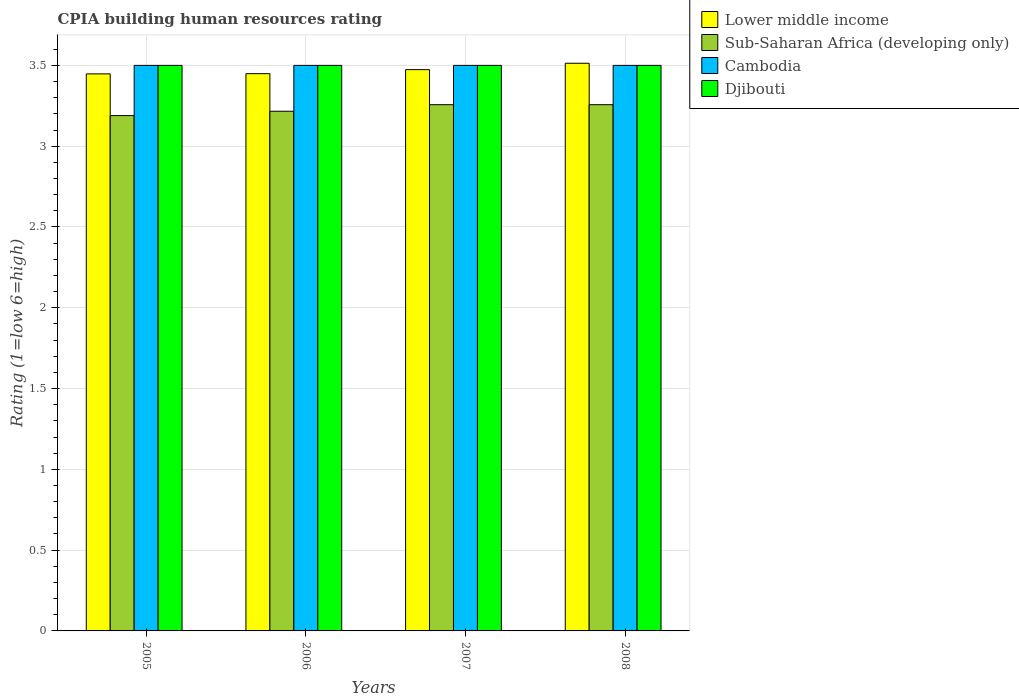How many different coloured bars are there?
Your response must be concise. 4. Are the number of bars per tick equal to the number of legend labels?
Your answer should be compact. Yes. In how many cases, is the number of bars for a given year not equal to the number of legend labels?
Provide a short and direct response. 0. What is the CPIA rating in Sub-Saharan Africa (developing only) in 2005?
Offer a very short reply. 3.19. Across all years, what is the minimum CPIA rating in Djibouti?
Your answer should be compact. 3.5. In which year was the CPIA rating in Sub-Saharan Africa (developing only) maximum?
Your answer should be compact. 2007. What is the difference between the CPIA rating in Sub-Saharan Africa (developing only) in 2005 and that in 2008?
Offer a very short reply. -0.07. What is the difference between the CPIA rating in Djibouti in 2007 and the CPIA rating in Cambodia in 2008?
Give a very brief answer. 0. What is the average CPIA rating in Sub-Saharan Africa (developing only) per year?
Offer a very short reply. 3.23. In the year 2008, what is the difference between the CPIA rating in Cambodia and CPIA rating in Lower middle income?
Your answer should be compact. -0.01. What is the ratio of the CPIA rating in Lower middle income in 2006 to that in 2008?
Your answer should be very brief. 0.98. Is the CPIA rating in Sub-Saharan Africa (developing only) in 2005 less than that in 2006?
Your answer should be compact. Yes. In how many years, is the CPIA rating in Lower middle income greater than the average CPIA rating in Lower middle income taken over all years?
Provide a succinct answer. 2. Is the sum of the CPIA rating in Sub-Saharan Africa (developing only) in 2005 and 2006 greater than the maximum CPIA rating in Cambodia across all years?
Your answer should be very brief. Yes. Is it the case that in every year, the sum of the CPIA rating in Sub-Saharan Africa (developing only) and CPIA rating in Djibouti is greater than the sum of CPIA rating in Cambodia and CPIA rating in Lower middle income?
Provide a short and direct response. No. What does the 1st bar from the left in 2006 represents?
Provide a short and direct response. Lower middle income. What does the 4th bar from the right in 2006 represents?
Your answer should be compact. Lower middle income. Is it the case that in every year, the sum of the CPIA rating in Sub-Saharan Africa (developing only) and CPIA rating in Djibouti is greater than the CPIA rating in Cambodia?
Provide a short and direct response. Yes. Are all the bars in the graph horizontal?
Your response must be concise. No. Are the values on the major ticks of Y-axis written in scientific E-notation?
Give a very brief answer. No. Does the graph contain any zero values?
Your response must be concise. No. Where does the legend appear in the graph?
Your answer should be compact. Top right. How many legend labels are there?
Keep it short and to the point. 4. How are the legend labels stacked?
Offer a very short reply. Vertical. What is the title of the graph?
Give a very brief answer. CPIA building human resources rating. What is the label or title of the Y-axis?
Offer a terse response. Rating (1=low 6=high). What is the Rating (1=low 6=high) in Lower middle income in 2005?
Ensure brevity in your answer.  3.45. What is the Rating (1=low 6=high) in Sub-Saharan Africa (developing only) in 2005?
Your response must be concise. 3.19. What is the Rating (1=low 6=high) of Djibouti in 2005?
Offer a terse response. 3.5. What is the Rating (1=low 6=high) in Lower middle income in 2006?
Your answer should be very brief. 3.45. What is the Rating (1=low 6=high) in Sub-Saharan Africa (developing only) in 2006?
Ensure brevity in your answer.  3.22. What is the Rating (1=low 6=high) in Cambodia in 2006?
Give a very brief answer. 3.5. What is the Rating (1=low 6=high) of Lower middle income in 2007?
Ensure brevity in your answer.  3.47. What is the Rating (1=low 6=high) of Sub-Saharan Africa (developing only) in 2007?
Make the answer very short. 3.26. What is the Rating (1=low 6=high) in Lower middle income in 2008?
Offer a terse response. 3.51. What is the Rating (1=low 6=high) of Sub-Saharan Africa (developing only) in 2008?
Your response must be concise. 3.26. What is the Rating (1=low 6=high) of Djibouti in 2008?
Keep it short and to the point. 3.5. Across all years, what is the maximum Rating (1=low 6=high) of Lower middle income?
Give a very brief answer. 3.51. Across all years, what is the maximum Rating (1=low 6=high) in Sub-Saharan Africa (developing only)?
Offer a terse response. 3.26. Across all years, what is the maximum Rating (1=low 6=high) of Cambodia?
Offer a very short reply. 3.5. Across all years, what is the minimum Rating (1=low 6=high) of Lower middle income?
Your response must be concise. 3.45. Across all years, what is the minimum Rating (1=low 6=high) of Sub-Saharan Africa (developing only)?
Give a very brief answer. 3.19. Across all years, what is the minimum Rating (1=low 6=high) of Cambodia?
Your response must be concise. 3.5. What is the total Rating (1=low 6=high) in Lower middle income in the graph?
Provide a succinct answer. 13.88. What is the total Rating (1=low 6=high) in Sub-Saharan Africa (developing only) in the graph?
Offer a terse response. 12.92. What is the total Rating (1=low 6=high) of Cambodia in the graph?
Give a very brief answer. 14. What is the difference between the Rating (1=low 6=high) in Lower middle income in 2005 and that in 2006?
Keep it short and to the point. -0. What is the difference between the Rating (1=low 6=high) in Sub-Saharan Africa (developing only) in 2005 and that in 2006?
Provide a short and direct response. -0.03. What is the difference between the Rating (1=low 6=high) of Cambodia in 2005 and that in 2006?
Your answer should be very brief. 0. What is the difference between the Rating (1=low 6=high) of Lower middle income in 2005 and that in 2007?
Provide a succinct answer. -0.03. What is the difference between the Rating (1=low 6=high) in Sub-Saharan Africa (developing only) in 2005 and that in 2007?
Your answer should be compact. -0.07. What is the difference between the Rating (1=low 6=high) of Cambodia in 2005 and that in 2007?
Your response must be concise. 0. What is the difference between the Rating (1=low 6=high) in Djibouti in 2005 and that in 2007?
Provide a succinct answer. 0. What is the difference between the Rating (1=low 6=high) in Lower middle income in 2005 and that in 2008?
Your answer should be very brief. -0.07. What is the difference between the Rating (1=low 6=high) of Sub-Saharan Africa (developing only) in 2005 and that in 2008?
Your response must be concise. -0.07. What is the difference between the Rating (1=low 6=high) in Djibouti in 2005 and that in 2008?
Your answer should be compact. 0. What is the difference between the Rating (1=low 6=high) in Lower middle income in 2006 and that in 2007?
Offer a very short reply. -0.03. What is the difference between the Rating (1=low 6=high) of Sub-Saharan Africa (developing only) in 2006 and that in 2007?
Ensure brevity in your answer.  -0.04. What is the difference between the Rating (1=low 6=high) of Cambodia in 2006 and that in 2007?
Your response must be concise. 0. What is the difference between the Rating (1=low 6=high) in Djibouti in 2006 and that in 2007?
Provide a succinct answer. 0. What is the difference between the Rating (1=low 6=high) in Lower middle income in 2006 and that in 2008?
Provide a succinct answer. -0.06. What is the difference between the Rating (1=low 6=high) in Sub-Saharan Africa (developing only) in 2006 and that in 2008?
Provide a short and direct response. -0.04. What is the difference between the Rating (1=low 6=high) in Djibouti in 2006 and that in 2008?
Offer a very short reply. 0. What is the difference between the Rating (1=low 6=high) in Lower middle income in 2007 and that in 2008?
Your answer should be very brief. -0.04. What is the difference between the Rating (1=low 6=high) of Cambodia in 2007 and that in 2008?
Give a very brief answer. 0. What is the difference between the Rating (1=low 6=high) in Djibouti in 2007 and that in 2008?
Ensure brevity in your answer.  0. What is the difference between the Rating (1=low 6=high) in Lower middle income in 2005 and the Rating (1=low 6=high) in Sub-Saharan Africa (developing only) in 2006?
Ensure brevity in your answer.  0.23. What is the difference between the Rating (1=low 6=high) of Lower middle income in 2005 and the Rating (1=low 6=high) of Cambodia in 2006?
Your answer should be very brief. -0.05. What is the difference between the Rating (1=low 6=high) in Lower middle income in 2005 and the Rating (1=low 6=high) in Djibouti in 2006?
Keep it short and to the point. -0.05. What is the difference between the Rating (1=low 6=high) of Sub-Saharan Africa (developing only) in 2005 and the Rating (1=low 6=high) of Cambodia in 2006?
Offer a very short reply. -0.31. What is the difference between the Rating (1=low 6=high) in Sub-Saharan Africa (developing only) in 2005 and the Rating (1=low 6=high) in Djibouti in 2006?
Provide a short and direct response. -0.31. What is the difference between the Rating (1=low 6=high) in Cambodia in 2005 and the Rating (1=low 6=high) in Djibouti in 2006?
Provide a short and direct response. 0. What is the difference between the Rating (1=low 6=high) of Lower middle income in 2005 and the Rating (1=low 6=high) of Sub-Saharan Africa (developing only) in 2007?
Provide a succinct answer. 0.19. What is the difference between the Rating (1=low 6=high) in Lower middle income in 2005 and the Rating (1=low 6=high) in Cambodia in 2007?
Make the answer very short. -0.05. What is the difference between the Rating (1=low 6=high) of Lower middle income in 2005 and the Rating (1=low 6=high) of Djibouti in 2007?
Provide a short and direct response. -0.05. What is the difference between the Rating (1=low 6=high) in Sub-Saharan Africa (developing only) in 2005 and the Rating (1=low 6=high) in Cambodia in 2007?
Keep it short and to the point. -0.31. What is the difference between the Rating (1=low 6=high) of Sub-Saharan Africa (developing only) in 2005 and the Rating (1=low 6=high) of Djibouti in 2007?
Provide a short and direct response. -0.31. What is the difference between the Rating (1=low 6=high) of Lower middle income in 2005 and the Rating (1=low 6=high) of Sub-Saharan Africa (developing only) in 2008?
Provide a succinct answer. 0.19. What is the difference between the Rating (1=low 6=high) of Lower middle income in 2005 and the Rating (1=low 6=high) of Cambodia in 2008?
Give a very brief answer. -0.05. What is the difference between the Rating (1=low 6=high) in Lower middle income in 2005 and the Rating (1=low 6=high) in Djibouti in 2008?
Make the answer very short. -0.05. What is the difference between the Rating (1=low 6=high) in Sub-Saharan Africa (developing only) in 2005 and the Rating (1=low 6=high) in Cambodia in 2008?
Offer a very short reply. -0.31. What is the difference between the Rating (1=low 6=high) of Sub-Saharan Africa (developing only) in 2005 and the Rating (1=low 6=high) of Djibouti in 2008?
Provide a short and direct response. -0.31. What is the difference between the Rating (1=low 6=high) of Cambodia in 2005 and the Rating (1=low 6=high) of Djibouti in 2008?
Provide a short and direct response. 0. What is the difference between the Rating (1=low 6=high) of Lower middle income in 2006 and the Rating (1=low 6=high) of Sub-Saharan Africa (developing only) in 2007?
Provide a succinct answer. 0.19. What is the difference between the Rating (1=low 6=high) of Lower middle income in 2006 and the Rating (1=low 6=high) of Cambodia in 2007?
Keep it short and to the point. -0.05. What is the difference between the Rating (1=low 6=high) in Lower middle income in 2006 and the Rating (1=low 6=high) in Djibouti in 2007?
Ensure brevity in your answer.  -0.05. What is the difference between the Rating (1=low 6=high) of Sub-Saharan Africa (developing only) in 2006 and the Rating (1=low 6=high) of Cambodia in 2007?
Your answer should be compact. -0.28. What is the difference between the Rating (1=low 6=high) of Sub-Saharan Africa (developing only) in 2006 and the Rating (1=low 6=high) of Djibouti in 2007?
Provide a succinct answer. -0.28. What is the difference between the Rating (1=low 6=high) in Lower middle income in 2006 and the Rating (1=low 6=high) in Sub-Saharan Africa (developing only) in 2008?
Your answer should be very brief. 0.19. What is the difference between the Rating (1=low 6=high) of Lower middle income in 2006 and the Rating (1=low 6=high) of Cambodia in 2008?
Make the answer very short. -0.05. What is the difference between the Rating (1=low 6=high) of Lower middle income in 2006 and the Rating (1=low 6=high) of Djibouti in 2008?
Provide a succinct answer. -0.05. What is the difference between the Rating (1=low 6=high) of Sub-Saharan Africa (developing only) in 2006 and the Rating (1=low 6=high) of Cambodia in 2008?
Provide a short and direct response. -0.28. What is the difference between the Rating (1=low 6=high) of Sub-Saharan Africa (developing only) in 2006 and the Rating (1=low 6=high) of Djibouti in 2008?
Provide a short and direct response. -0.28. What is the difference between the Rating (1=low 6=high) of Cambodia in 2006 and the Rating (1=low 6=high) of Djibouti in 2008?
Keep it short and to the point. 0. What is the difference between the Rating (1=low 6=high) in Lower middle income in 2007 and the Rating (1=low 6=high) in Sub-Saharan Africa (developing only) in 2008?
Your response must be concise. 0.22. What is the difference between the Rating (1=low 6=high) in Lower middle income in 2007 and the Rating (1=low 6=high) in Cambodia in 2008?
Your answer should be very brief. -0.03. What is the difference between the Rating (1=low 6=high) in Lower middle income in 2007 and the Rating (1=low 6=high) in Djibouti in 2008?
Your answer should be very brief. -0.03. What is the difference between the Rating (1=low 6=high) of Sub-Saharan Africa (developing only) in 2007 and the Rating (1=low 6=high) of Cambodia in 2008?
Provide a short and direct response. -0.24. What is the difference between the Rating (1=low 6=high) of Sub-Saharan Africa (developing only) in 2007 and the Rating (1=low 6=high) of Djibouti in 2008?
Give a very brief answer. -0.24. What is the difference between the Rating (1=low 6=high) in Cambodia in 2007 and the Rating (1=low 6=high) in Djibouti in 2008?
Provide a succinct answer. 0. What is the average Rating (1=low 6=high) in Lower middle income per year?
Offer a terse response. 3.47. What is the average Rating (1=low 6=high) of Sub-Saharan Africa (developing only) per year?
Make the answer very short. 3.23. In the year 2005, what is the difference between the Rating (1=low 6=high) of Lower middle income and Rating (1=low 6=high) of Sub-Saharan Africa (developing only)?
Provide a succinct answer. 0.26. In the year 2005, what is the difference between the Rating (1=low 6=high) of Lower middle income and Rating (1=low 6=high) of Cambodia?
Your answer should be compact. -0.05. In the year 2005, what is the difference between the Rating (1=low 6=high) of Lower middle income and Rating (1=low 6=high) of Djibouti?
Provide a succinct answer. -0.05. In the year 2005, what is the difference between the Rating (1=low 6=high) of Sub-Saharan Africa (developing only) and Rating (1=low 6=high) of Cambodia?
Keep it short and to the point. -0.31. In the year 2005, what is the difference between the Rating (1=low 6=high) of Sub-Saharan Africa (developing only) and Rating (1=low 6=high) of Djibouti?
Offer a terse response. -0.31. In the year 2005, what is the difference between the Rating (1=low 6=high) in Cambodia and Rating (1=low 6=high) in Djibouti?
Keep it short and to the point. 0. In the year 2006, what is the difference between the Rating (1=low 6=high) in Lower middle income and Rating (1=low 6=high) in Sub-Saharan Africa (developing only)?
Your answer should be compact. 0.23. In the year 2006, what is the difference between the Rating (1=low 6=high) in Lower middle income and Rating (1=low 6=high) in Cambodia?
Make the answer very short. -0.05. In the year 2006, what is the difference between the Rating (1=low 6=high) of Lower middle income and Rating (1=low 6=high) of Djibouti?
Make the answer very short. -0.05. In the year 2006, what is the difference between the Rating (1=low 6=high) in Sub-Saharan Africa (developing only) and Rating (1=low 6=high) in Cambodia?
Offer a very short reply. -0.28. In the year 2006, what is the difference between the Rating (1=low 6=high) of Sub-Saharan Africa (developing only) and Rating (1=low 6=high) of Djibouti?
Your answer should be very brief. -0.28. In the year 2006, what is the difference between the Rating (1=low 6=high) in Cambodia and Rating (1=low 6=high) in Djibouti?
Offer a terse response. 0. In the year 2007, what is the difference between the Rating (1=low 6=high) in Lower middle income and Rating (1=low 6=high) in Sub-Saharan Africa (developing only)?
Your answer should be compact. 0.22. In the year 2007, what is the difference between the Rating (1=low 6=high) in Lower middle income and Rating (1=low 6=high) in Cambodia?
Your answer should be very brief. -0.03. In the year 2007, what is the difference between the Rating (1=low 6=high) in Lower middle income and Rating (1=low 6=high) in Djibouti?
Your answer should be very brief. -0.03. In the year 2007, what is the difference between the Rating (1=low 6=high) in Sub-Saharan Africa (developing only) and Rating (1=low 6=high) in Cambodia?
Provide a short and direct response. -0.24. In the year 2007, what is the difference between the Rating (1=low 6=high) in Sub-Saharan Africa (developing only) and Rating (1=low 6=high) in Djibouti?
Keep it short and to the point. -0.24. In the year 2007, what is the difference between the Rating (1=low 6=high) in Cambodia and Rating (1=low 6=high) in Djibouti?
Offer a terse response. 0. In the year 2008, what is the difference between the Rating (1=low 6=high) of Lower middle income and Rating (1=low 6=high) of Sub-Saharan Africa (developing only)?
Give a very brief answer. 0.26. In the year 2008, what is the difference between the Rating (1=low 6=high) of Lower middle income and Rating (1=low 6=high) of Cambodia?
Make the answer very short. 0.01. In the year 2008, what is the difference between the Rating (1=low 6=high) of Lower middle income and Rating (1=low 6=high) of Djibouti?
Your answer should be very brief. 0.01. In the year 2008, what is the difference between the Rating (1=low 6=high) of Sub-Saharan Africa (developing only) and Rating (1=low 6=high) of Cambodia?
Offer a very short reply. -0.24. In the year 2008, what is the difference between the Rating (1=low 6=high) in Sub-Saharan Africa (developing only) and Rating (1=low 6=high) in Djibouti?
Offer a very short reply. -0.24. What is the ratio of the Rating (1=low 6=high) in Lower middle income in 2005 to that in 2006?
Offer a terse response. 1. What is the ratio of the Rating (1=low 6=high) in Lower middle income in 2005 to that in 2007?
Give a very brief answer. 0.99. What is the ratio of the Rating (1=low 6=high) of Sub-Saharan Africa (developing only) in 2005 to that in 2007?
Ensure brevity in your answer.  0.98. What is the ratio of the Rating (1=low 6=high) of Cambodia in 2005 to that in 2007?
Offer a very short reply. 1. What is the ratio of the Rating (1=low 6=high) in Djibouti in 2005 to that in 2007?
Offer a terse response. 1. What is the ratio of the Rating (1=low 6=high) of Lower middle income in 2005 to that in 2008?
Provide a short and direct response. 0.98. What is the ratio of the Rating (1=low 6=high) of Sub-Saharan Africa (developing only) in 2005 to that in 2008?
Ensure brevity in your answer.  0.98. What is the ratio of the Rating (1=low 6=high) of Cambodia in 2005 to that in 2008?
Your answer should be compact. 1. What is the ratio of the Rating (1=low 6=high) in Lower middle income in 2006 to that in 2007?
Make the answer very short. 0.99. What is the ratio of the Rating (1=low 6=high) of Sub-Saharan Africa (developing only) in 2006 to that in 2007?
Your answer should be compact. 0.99. What is the ratio of the Rating (1=low 6=high) in Djibouti in 2006 to that in 2007?
Provide a succinct answer. 1. What is the ratio of the Rating (1=low 6=high) of Lower middle income in 2006 to that in 2008?
Your answer should be very brief. 0.98. What is the ratio of the Rating (1=low 6=high) of Sub-Saharan Africa (developing only) in 2006 to that in 2008?
Your response must be concise. 0.99. What is the ratio of the Rating (1=low 6=high) in Lower middle income in 2007 to that in 2008?
Give a very brief answer. 0.99. What is the ratio of the Rating (1=low 6=high) of Sub-Saharan Africa (developing only) in 2007 to that in 2008?
Your answer should be compact. 1. What is the ratio of the Rating (1=low 6=high) in Cambodia in 2007 to that in 2008?
Offer a very short reply. 1. What is the difference between the highest and the second highest Rating (1=low 6=high) in Lower middle income?
Give a very brief answer. 0.04. What is the difference between the highest and the second highest Rating (1=low 6=high) in Cambodia?
Your answer should be compact. 0. What is the difference between the highest and the second highest Rating (1=low 6=high) of Djibouti?
Your response must be concise. 0. What is the difference between the highest and the lowest Rating (1=low 6=high) of Lower middle income?
Provide a short and direct response. 0.07. What is the difference between the highest and the lowest Rating (1=low 6=high) of Sub-Saharan Africa (developing only)?
Provide a succinct answer. 0.07. What is the difference between the highest and the lowest Rating (1=low 6=high) of Cambodia?
Make the answer very short. 0. 